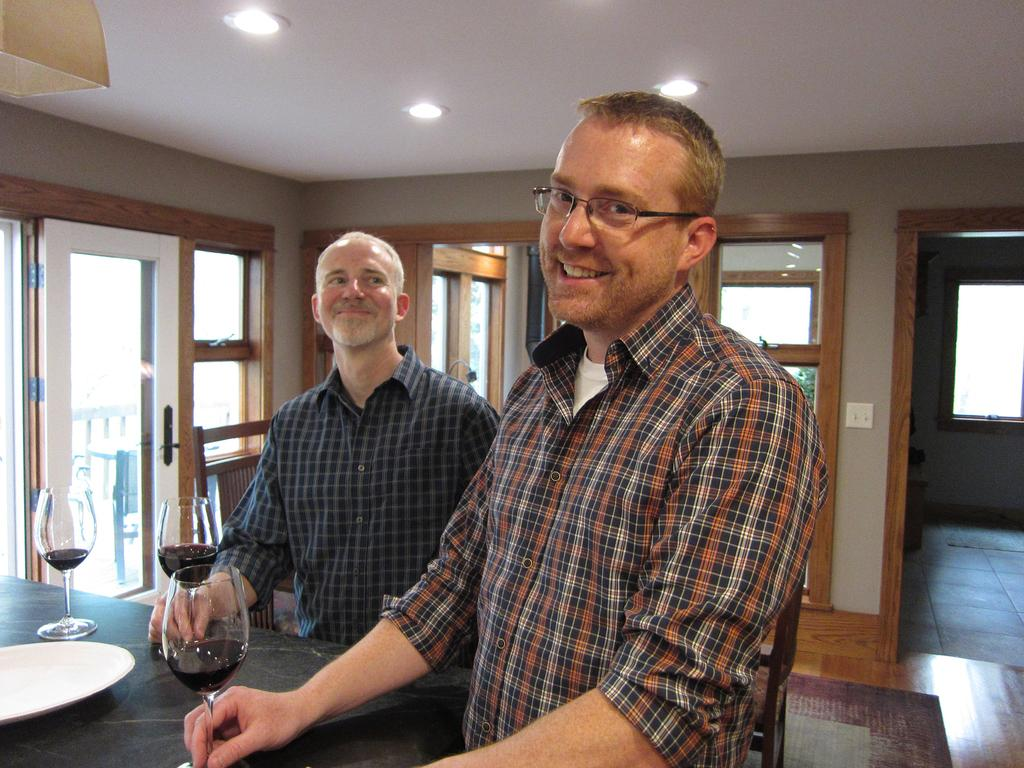How many people are in the image? There are two people in the image. What are the people doing in the image? The people are standing and smiling. What objects are in front of the people? There is a plate and a wine glass in front of the people. What can be seen in the background of the image? There is a wall, a window, and lights in the background of the image. What type of property can be seen in the background of the image? There is no property visible in the background of the image. How does the downtown area look like in the image? There is no downtown area present in the image. 